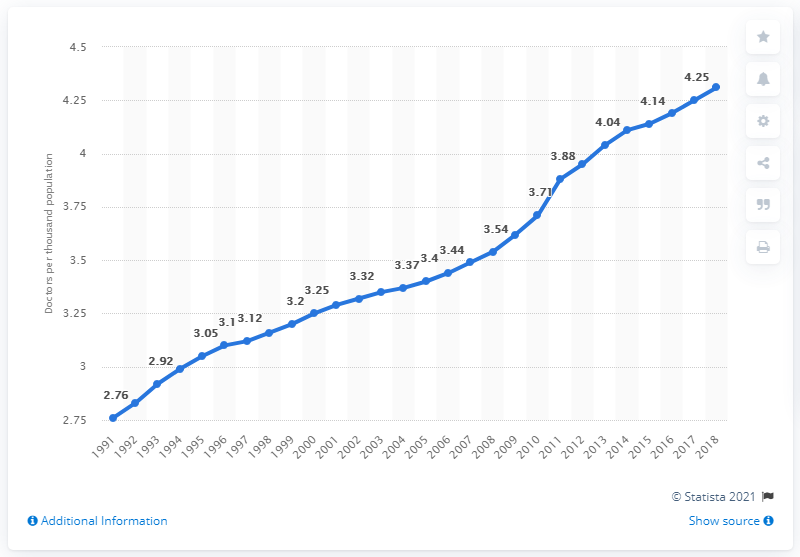Highlight a few significant elements in this photo. In 2018, there were approximately 4.31 practicing doctors per 1,000 people in Germany. 